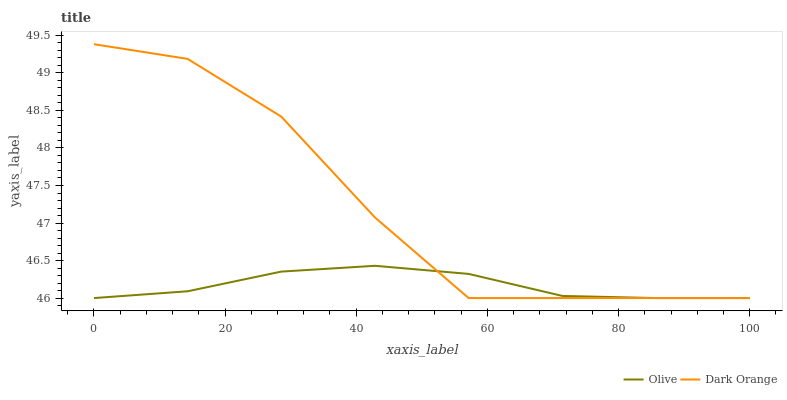Does Olive have the minimum area under the curve?
Answer yes or no. Yes. Does Dark Orange have the maximum area under the curve?
Answer yes or no. Yes. Does Dark Orange have the minimum area under the curve?
Answer yes or no. No. Is Olive the smoothest?
Answer yes or no. Yes. Is Dark Orange the roughest?
Answer yes or no. Yes. Is Dark Orange the smoothest?
Answer yes or no. No. Does Olive have the lowest value?
Answer yes or no. Yes. Does Dark Orange have the highest value?
Answer yes or no. Yes. Does Olive intersect Dark Orange?
Answer yes or no. Yes. Is Olive less than Dark Orange?
Answer yes or no. No. Is Olive greater than Dark Orange?
Answer yes or no. No. 